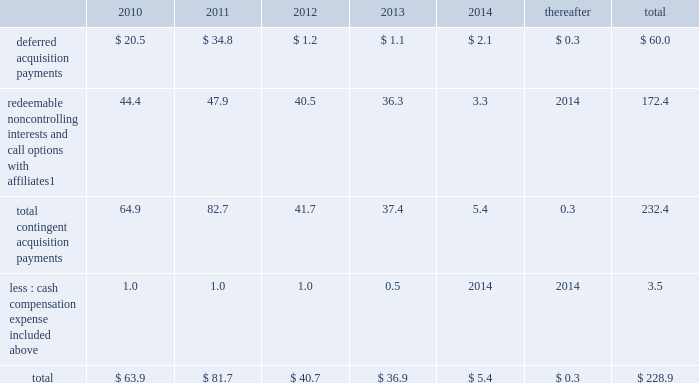Notes to consolidated financial statements 2013 ( continued ) ( amounts in millions , except per share amounts ) guarantees we have guarantees of certain obligations of our subsidiaries relating principally to credit facilities , certain media payables and operating leases of certain subsidiaries .
The amount of such parent company guarantees was $ 769.3 and $ 706.7 as of december 31 , 2009 and 2008 , respectively .
In the event of non-payment by the applicable subsidiary of the obligations covered by a guarantee , we would be obligated to pay the amounts covered by that guarantee .
As of december 31 , 2009 , there are no material assets pledged as security for such parent company guarantees .
Contingent acquisition obligations the table details the estimated future contingent acquisition obligations payable in cash as of december 31 , 2009 .
The estimated amounts listed would be paid in the event of exercise at the earliest exercise date .
See note 6 for further information relating to the payment structure of our acquisitions .
All payments are contingent upon achieving projected operating performance targets and satisfying other conditions specified in the related agreements and are subject to revisions as the earn-out periods progress. .
1 we have entered into certain acquisitions that contain both redeemable noncontrolling interests and call options with similar terms and conditions .
In such instances , we have included the related estimated contingent acquisition obligation in the period when the earliest related option is exercisable .
We have certain redeemable noncontrolling interests that are exercisable at the discretion of the noncontrolling equity owners as of december 31 , 2009 .
As such , these estimated acquisition payments of $ 20.5 have been included within the total payments expected to be made in 2010 in the table and , if not made in 2010 , will continue to carry forward into 2011 or beyond until they are exercised or expire .
Redeemable noncontrolling interests are included in the table at current exercise price payable in cash , not at applicable redemption value in accordance with the authoritative guidance for classification and measurement of redeemable securities .
Legal matters we are involved in legal and administrative proceedings of various types .
While any litigation contains an element of uncertainty , we do not believe that the outcome of such proceedings will have a material adverse effect on our financial condition , results of operations or cash flows .
Note 16 : recent accounting standards in december 2009 , the financial accounting standards board ( 201cfasb 201d ) amended authoritative guidance related to accounting for transfers and servicing of financial assets and extinguishments of liabilities .
The guidance will be effective for the company beginning january 1 , 2010 .
The guidance eliminates the concept of a qualifying special-purpose entity and changes the criteria for derecognizing financial assets .
In addition , the guidance will require additional disclosures related to a company 2019s continued involvement with financial assets that have been transferred .
We do not expect the adoption of this amended guidance to have a significant impact on our consolidated financial statements .
In december 2009 , the fasb amended authoritative guidance for consolidating variable interest entities .
The guidance will be effective for the company beginning january 1 , 2010 .
Specifically , the guidance revises factors that should be considered by a reporting entity when determining whether an entity that is insufficiently capitalized or is not controlled through voting ( or similar rights ) should be consolidated .
This guidance also includes revised financial statement disclosures regarding the reporting entity 2019s involvement , including significant risk exposures as a result of that involvement , and the impact the relationship has on the reporting entity 2019s financial statements .
We are currently evaluating the potential impact of the amended guidance on our consolidated financial statements. .
What percentage decrease occurred from 2011-2012 for deferred acquisition payments? 
Computations: (((34.8 - 1.2) / 34.8) * 100)
Answer: 96.55172. Notes to consolidated financial statements 2013 ( continued ) ( amounts in millions , except per share amounts ) guarantees we have guarantees of certain obligations of our subsidiaries relating principally to credit facilities , certain media payables and operating leases of certain subsidiaries .
The amount of such parent company guarantees was $ 769.3 and $ 706.7 as of december 31 , 2009 and 2008 , respectively .
In the event of non-payment by the applicable subsidiary of the obligations covered by a guarantee , we would be obligated to pay the amounts covered by that guarantee .
As of december 31 , 2009 , there are no material assets pledged as security for such parent company guarantees .
Contingent acquisition obligations the table details the estimated future contingent acquisition obligations payable in cash as of december 31 , 2009 .
The estimated amounts listed would be paid in the event of exercise at the earliest exercise date .
See note 6 for further information relating to the payment structure of our acquisitions .
All payments are contingent upon achieving projected operating performance targets and satisfying other conditions specified in the related agreements and are subject to revisions as the earn-out periods progress. .
1 we have entered into certain acquisitions that contain both redeemable noncontrolling interests and call options with similar terms and conditions .
In such instances , we have included the related estimated contingent acquisition obligation in the period when the earliest related option is exercisable .
We have certain redeemable noncontrolling interests that are exercisable at the discretion of the noncontrolling equity owners as of december 31 , 2009 .
As such , these estimated acquisition payments of $ 20.5 have been included within the total payments expected to be made in 2010 in the table and , if not made in 2010 , will continue to carry forward into 2011 or beyond until they are exercised or expire .
Redeemable noncontrolling interests are included in the table at current exercise price payable in cash , not at applicable redemption value in accordance with the authoritative guidance for classification and measurement of redeemable securities .
Legal matters we are involved in legal and administrative proceedings of various types .
While any litigation contains an element of uncertainty , we do not believe that the outcome of such proceedings will have a material adverse effect on our financial condition , results of operations or cash flows .
Note 16 : recent accounting standards in december 2009 , the financial accounting standards board ( 201cfasb 201d ) amended authoritative guidance related to accounting for transfers and servicing of financial assets and extinguishments of liabilities .
The guidance will be effective for the company beginning january 1 , 2010 .
The guidance eliminates the concept of a qualifying special-purpose entity and changes the criteria for derecognizing financial assets .
In addition , the guidance will require additional disclosures related to a company 2019s continued involvement with financial assets that have been transferred .
We do not expect the adoption of this amended guidance to have a significant impact on our consolidated financial statements .
In december 2009 , the fasb amended authoritative guidance for consolidating variable interest entities .
The guidance will be effective for the company beginning january 1 , 2010 .
Specifically , the guidance revises factors that should be considered by a reporting entity when determining whether an entity that is insufficiently capitalized or is not controlled through voting ( or similar rights ) should be consolidated .
This guidance also includes revised financial statement disclosures regarding the reporting entity 2019s involvement , including significant risk exposures as a result of that involvement , and the impact the relationship has on the reporting entity 2019s financial statements .
We are currently evaluating the potential impact of the amended guidance on our consolidated financial statements. .
What was the total amount , from 2008-2009 of guarantees of certain obligations of our subsidiaries relating principally to credit facilities , certain media payables and operating leases of certain subsidiaries , in millions? 
Computations: (769.3 + 706.7)
Answer: 1476.0. 